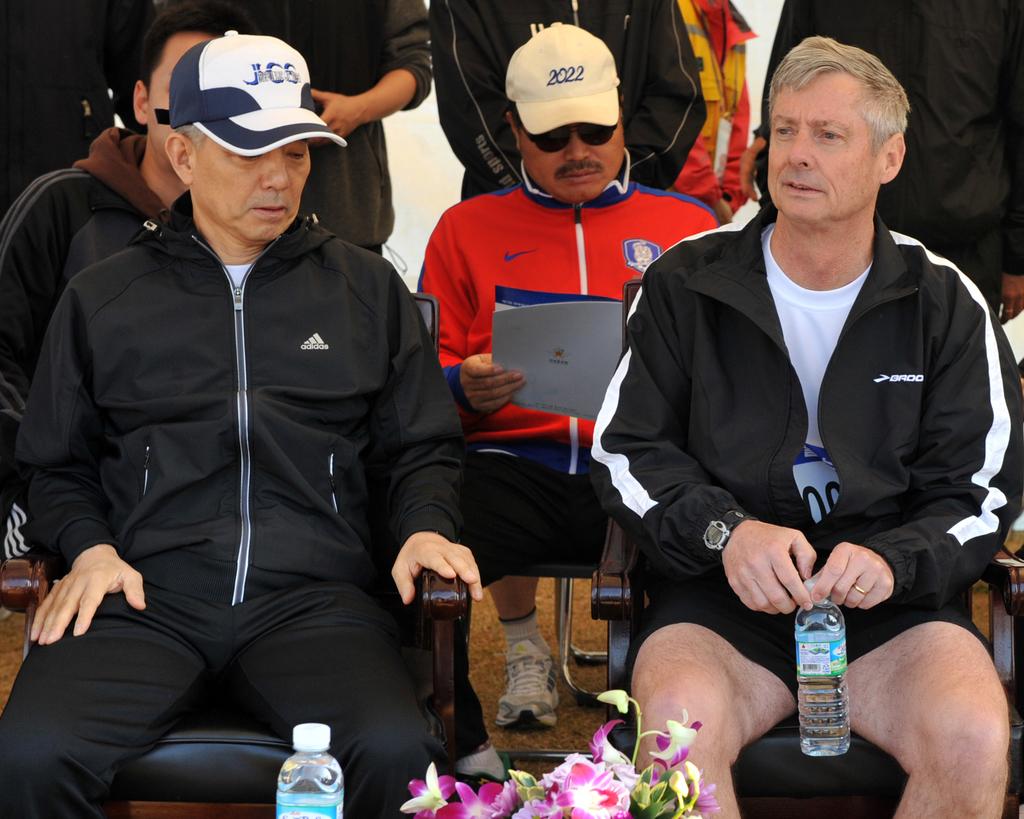What is the number on the right hat?
Provide a short and direct response. 2022. What does the hat in the front say?
Keep it short and to the point. Jcs. 